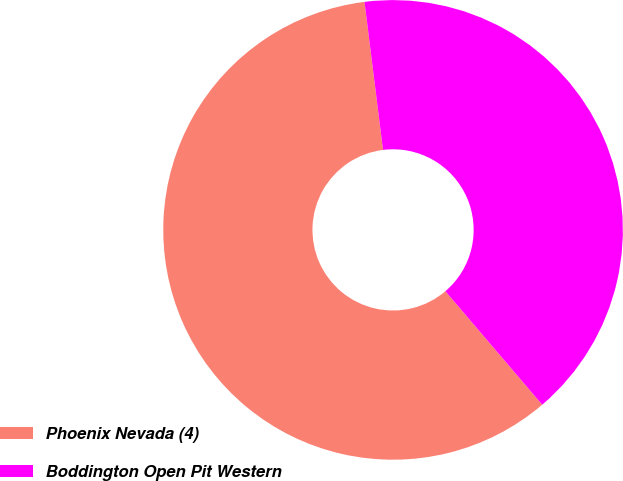Convert chart to OTSL. <chart><loc_0><loc_0><loc_500><loc_500><pie_chart><fcel>Phoenix Nevada (4)<fcel>Boddington Open Pit Western<nl><fcel>59.26%<fcel>40.74%<nl></chart> 